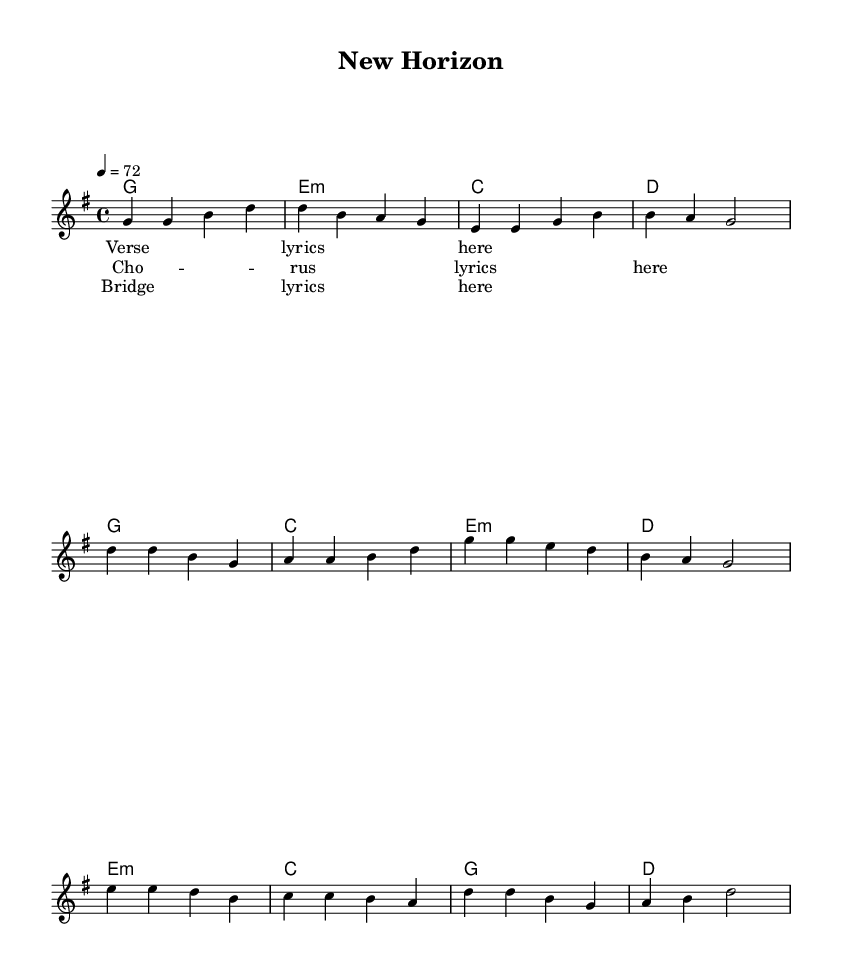What is the key signature of this music? The key signature is G major, as indicated by the one sharp (F#) shown at the beginning of the staff.
Answer: G major What is the time signature of this music? The time signature is 4/4, which means there are four beats in each measure and the quarter note gets one beat. This is shown at the beginning of the score.
Answer: 4/4 What is the tempo marking in this music? The tempo marking is 72 beats per minute, indicated at the beginning of the score with "4 = 72." This tells us the speed at which the piece should be played.
Answer: 72 How many measures are in the chorus? The chorus consists of four measures as seen by counting the measures laid out between the bar lines in the marked section of the score.
Answer: 4 What is the harmonic progression used in the verse? The harmonic progression follows G, E minor, C, and D, as indicated in the chord mode section corresponding to the verse.
Answer: G, E minor, C, D What different sections are present in this sheet music? The sheet music contains three sections labeled as verse, chorus, and bridge, which are typical structural elements in country rock music, representing different parts of the song.
Answer: Verse, Chorus, Bridge What theme is primarily expressed in the lyrics of this ballad? The theme primarily expressed is the immigrant experience and finding a new home, as indicated by the title "New Horizon" and the context of the lyrics.
Answer: Immigrant experience 